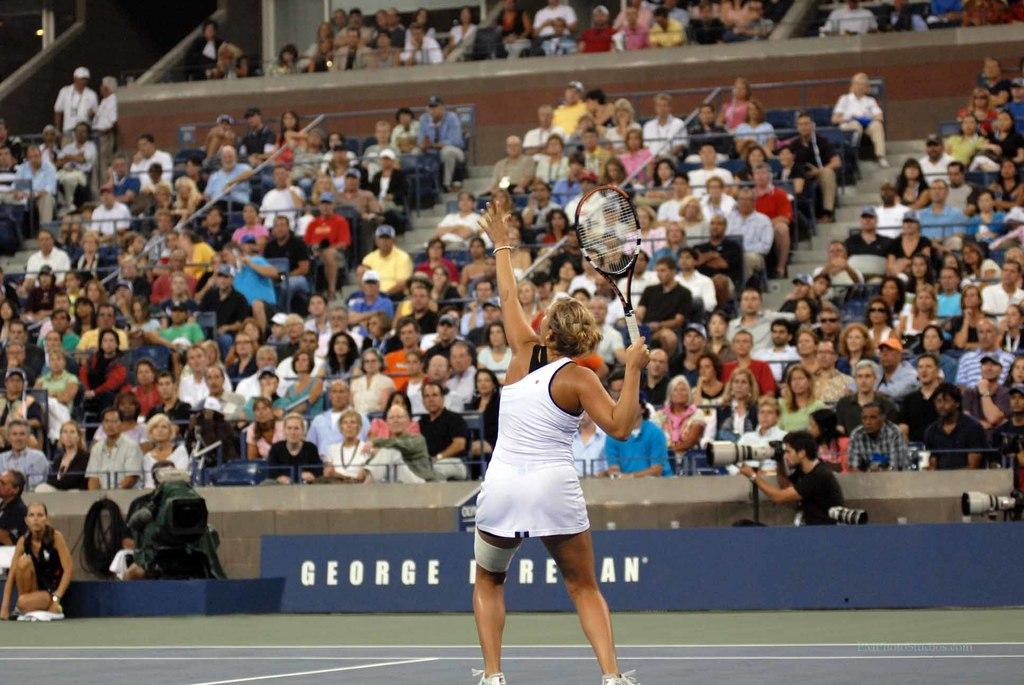Who is the main subject in the image? There is a woman in the image. What is the woman doing in the image? The woman is playing tennis. What can be seen in the background of the image? There is a camera, a hoarding, and a group of people sitting in a stadium. What type of bell can be heard ringing during the woman's tennis match in the image? There is no bell present or mentioned in the image, and therefore no such sound can be heard. 